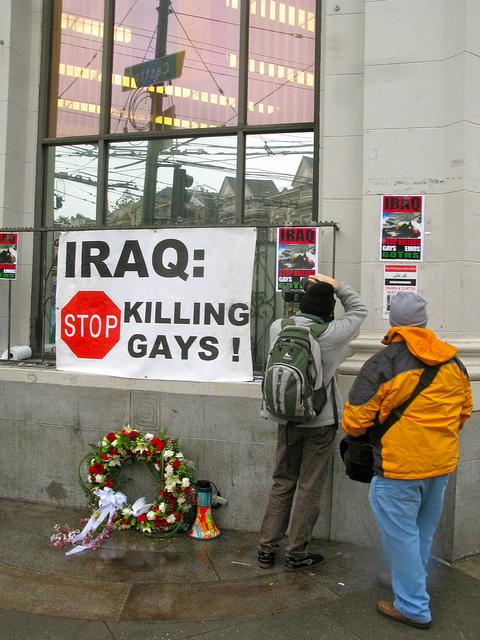What type of death might the Wreath commemorate?

Choices:
A) iraqi president
B) soldier
C) gay person
D) enemy fighter gay person 